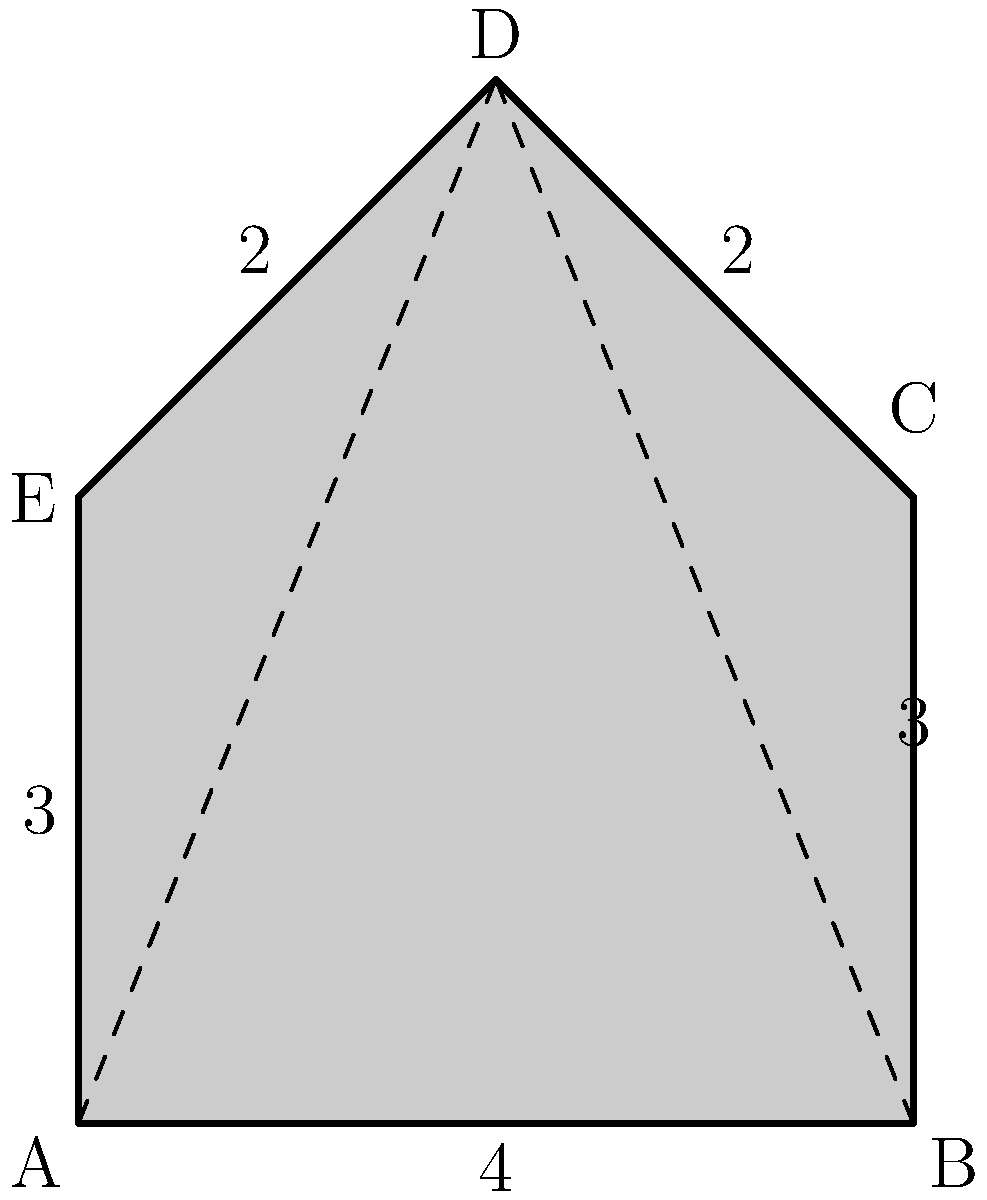As a criminal justice professional, you're tasked with calculating the area of a police badge for a new design. The badge is shaped like a pentagon, as shown in the diagram. Given that AB = 4 units, BC = 3 units, and the height of the triangle BCD is 2 units, calculate the total area of the badge. To calculate the area of the police badge, we'll divide it into three parts: a rectangle (ABCE) and two triangles (BCD and ADE).

1. Area of rectangle ABCE:
   $A_{ABCE} = AB \times AE = 4 \times 3 = 12$ square units

2. Area of triangle BCD:
   $A_{BCD} = \frac{1}{2} \times BC \times height = \frac{1}{2} \times 3 \times 2 = 3$ square units

3. Area of triangle ADE:
   The base (AE) is 3 units, and the height is the same as triangle BCD (2 units).
   $A_{ADE} = \frac{1}{2} \times AE \times height = \frac{1}{2} \times 3 \times 2 = 3$ square units

4. Total area of the badge:
   $A_{total} = A_{ABCE} + A_{BCD} + A_{ADE} = 12 + 3 + 3 = 18$ square units

Therefore, the total area of the police badge is 18 square units.
Answer: 18 square units 